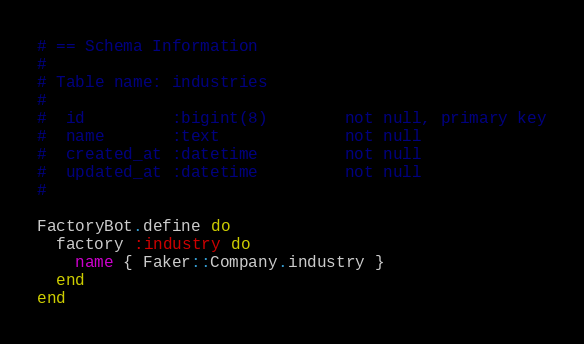<code> <loc_0><loc_0><loc_500><loc_500><_Ruby_># == Schema Information
#
# Table name: industries
#
#  id         :bigint(8)        not null, primary key
#  name       :text             not null
#  created_at :datetime         not null
#  updated_at :datetime         not null
#

FactoryBot.define do
  factory :industry do
    name { Faker::Company.industry }
  end
end
</code> 